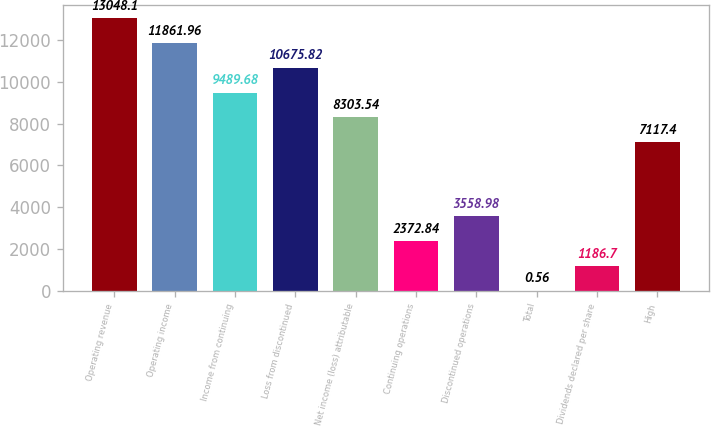Convert chart. <chart><loc_0><loc_0><loc_500><loc_500><bar_chart><fcel>Operating revenue<fcel>Operating income<fcel>Income from continuing<fcel>Loss from discontinued<fcel>Net income (loss) attributable<fcel>Continuing operations<fcel>Discontinued operations<fcel>Total<fcel>Dividends declared per share<fcel>High<nl><fcel>13048.1<fcel>11862<fcel>9489.68<fcel>10675.8<fcel>8303.54<fcel>2372.84<fcel>3558.98<fcel>0.56<fcel>1186.7<fcel>7117.4<nl></chart> 